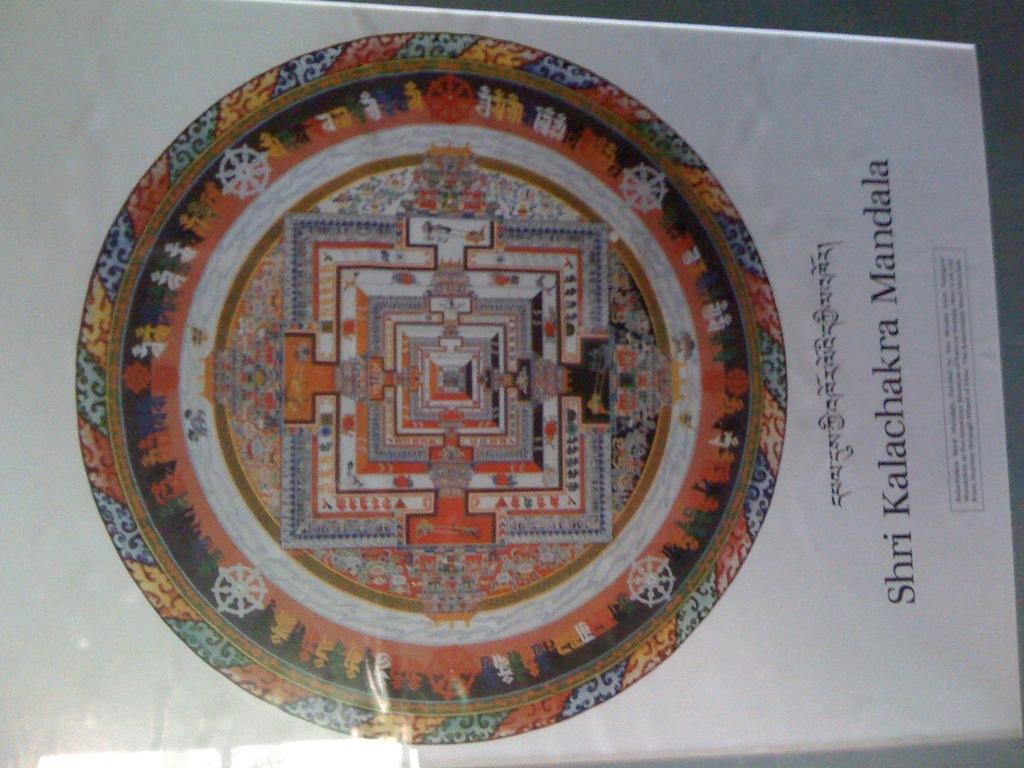Provide a one-sentence caption for the provided image. A Buddhist symbol which is round in shape with tapestry designs and "Shiri Kalachakra Mandala" in print under the symbol along with some other script. 